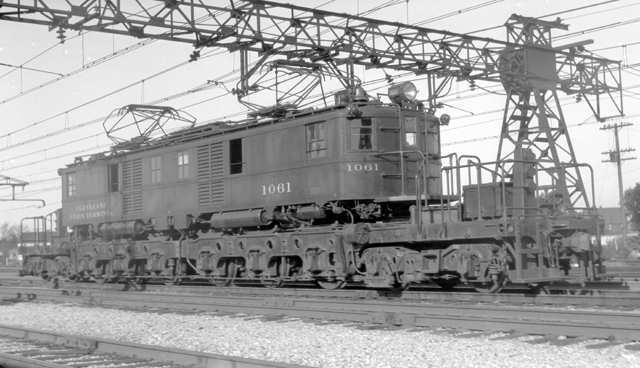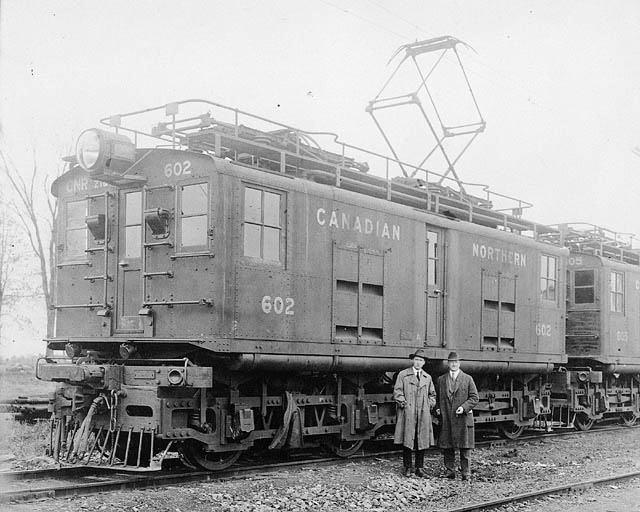The first image is the image on the left, the second image is the image on the right. Examine the images to the left and right. Is the description "Two trains are both heading towards the left direction." accurate? Answer yes or no. No. 